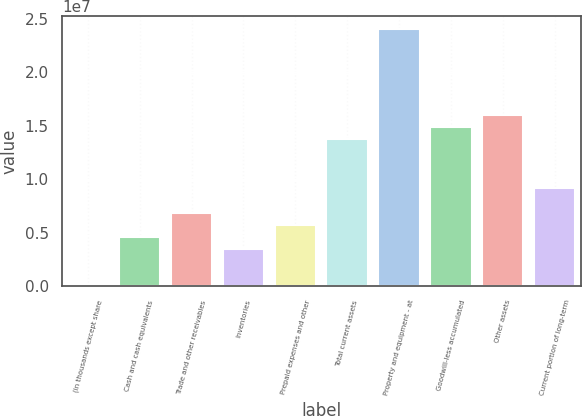Convert chart to OTSL. <chart><loc_0><loc_0><loc_500><loc_500><bar_chart><fcel>(in thousands except share<fcel>Cash and cash equivalents<fcel>Trade and other receivables<fcel>Inventories<fcel>Prepaid expenses and other<fcel>Total current assets<fcel>Property and equipment - at<fcel>Goodwill-less accumulated<fcel>Other assets<fcel>Current portion of long-term<nl><fcel>2006<fcel>4.57285e+06<fcel>6.85827e+06<fcel>3.43014e+06<fcel>5.71556e+06<fcel>1.37145e+07<fcel>2.39989e+07<fcel>1.48572e+07<fcel>1.59999e+07<fcel>9.14369e+06<nl></chart> 